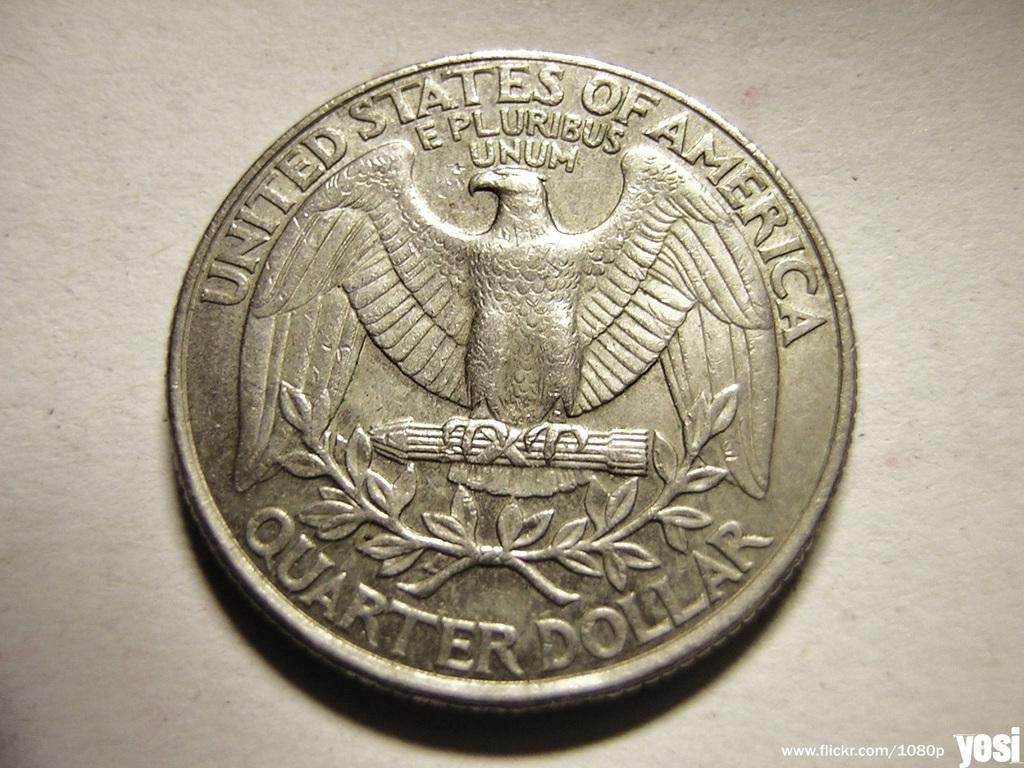<image>
Share a concise interpretation of the image provided. a silver quarter that says 'united states of america' at the top 